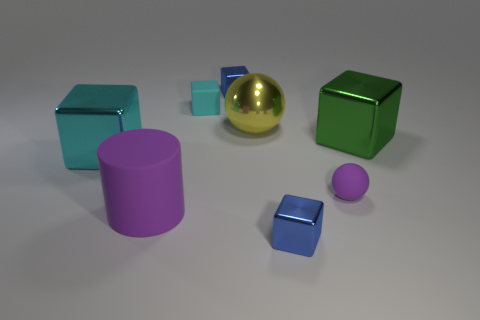How big is the purple cylinder that is in front of the large yellow thing that is on the left side of the blue object in front of the small purple rubber object?
Make the answer very short. Large. Is the number of big metal blocks greater than the number of metal blocks?
Give a very brief answer. No. There is a tiny shiny thing that is behind the rubber ball; is it the same color as the block that is in front of the rubber cylinder?
Provide a short and direct response. Yes. Do the cyan block behind the green thing and the purple object that is behind the big purple thing have the same material?
Provide a short and direct response. Yes. What number of rubber things are the same size as the rubber sphere?
Your response must be concise. 1. Are there fewer cyan cubes than large cylinders?
Your response must be concise. No. The big object that is right of the matte object right of the big yellow ball is what shape?
Make the answer very short. Cube. The yellow thing that is the same size as the green thing is what shape?
Give a very brief answer. Sphere. Is there another cyan metallic object that has the same shape as the large cyan object?
Your answer should be compact. No. What is the material of the large cyan thing?
Your response must be concise. Metal. 